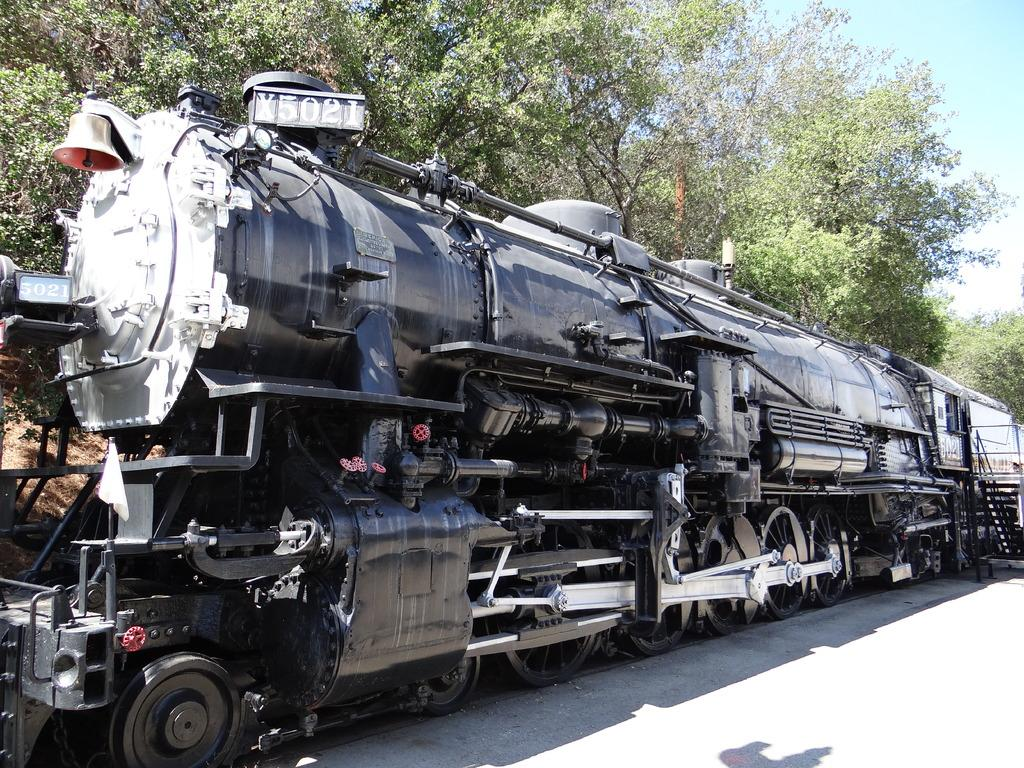What is the main subject of the image? The main subject of the image is an engine of a train. What color is the train engine? The train engine is black in color. What can be seen in the background of the image? There are trees visible in the image. What part of the sky is visible in the image? The sky is visible on the right side of the image. Can you tell me how many laborers are working on the train engine in the image? There are no laborers present in the image; it only shows the train engine. What type of badge is the train conductor wearing in the image? There is no train conductor or badge present in the image; it only shows the train engine. 